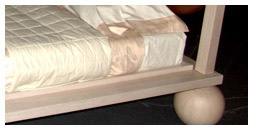Describe the objects in this image and their specific colors. I can see a bed in white, beige, tan, and darkgray tones in this image. 